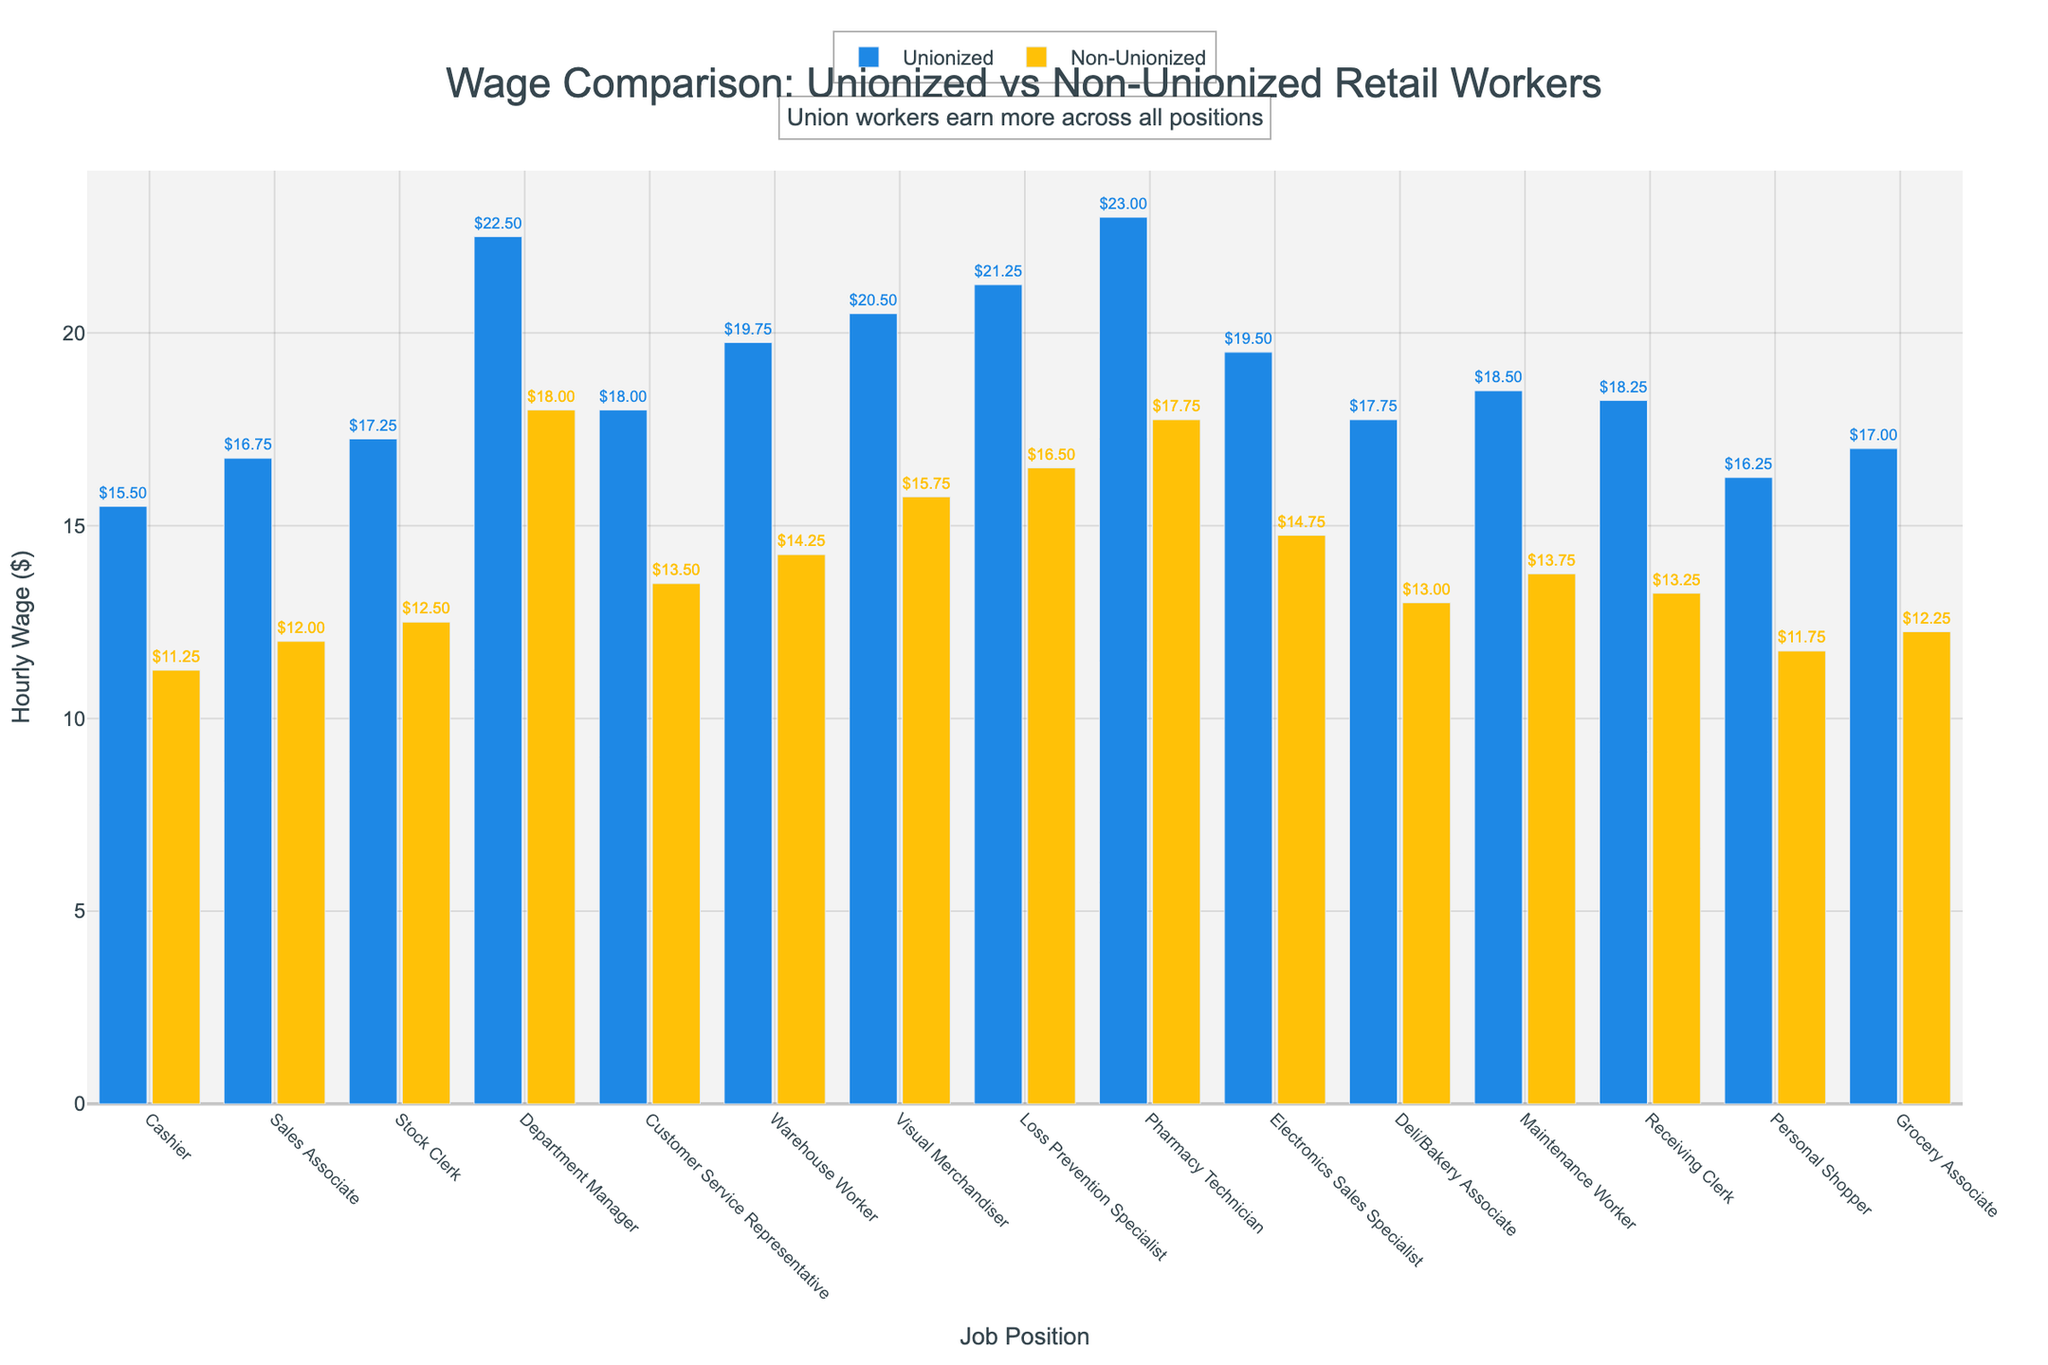What is the wage difference between unionized and non-unionized Cashiers? The wage of unionized Cashiers is $15.50, and non-unionized Cashiers is $11.25. The difference is $15.50 - $11.25.
Answer: $4.25 Which job position has the highest unionized wage and what is it? The Pharmacy Technician has the highest unionized wage at $23.00.
Answer: Pharmacy Technician, $23.00 How much more does a unionized Warehouse Worker earn compared to a non-unionized Warehouse Worker? The unionized Warehouse Worker earns $19.75, and the non-unionized one earns $14.25. The difference is $19.75 - $14.25.
Answer: $5.50 What is the average non-unionized wage for the positions that start with 'S'? Sales Associate earns $12.00, Stock Clerk earns $12.50. The average is ($12.00 + $12.50)/2.
Answer: $12.25 Which job position shows the smallest wage difference between unionized and non-unionized workers? The Department Manager has the smallest difference. Unionized wage is $22.50, non-unionized wage is $18.00. Difference is $22.50 - $18.00.
Answer: Department Manager, $4.50 How much more does a unionized Customer Service Representative earn than a non-unionized Maintenance Worker? The unionized Customer Service Representative earns $18.00, and the non-unionized Maintenance Worker earns $13.75. The difference is $18.00 - $13.75.
Answer: $4.25 Identify the job position with the widest wage gap between unionized and non-unionized workers and state the gap. Calculate the difference for each position; the Warehouse Worker has the widest gap: $19.75 - $14.25 = $5.50.
Answer: Warehouse Worker, $5.50 What is the combined wage of unionized and non-unionized Grocery Associates? The unionized Grocery Associate earns $17.00, and non-unionized earns $12.25. The combined wage is $17.00 + $12.25.
Answer: $29.25 What is the ratio of unionized to non-unionized wages for a Visual Merchandiser? The unionized wage is $20.50 and the non-unionized wage is $15.75. The ratio is $20.50 / $15.75.
Answer: 1.30 Compare the wage for unionized Deli/Bakery Associates to non-unionized Electronics Sales Specialists. Deli/Bakery Associate earns $17.75, Electronics Sales Specialist earns $14.75. Compare $17.75 to $14.75.
Answer: $3.00 more 